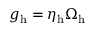<formula> <loc_0><loc_0><loc_500><loc_500>g _ { h } = \eta _ { h } \Omega _ { h }</formula> 